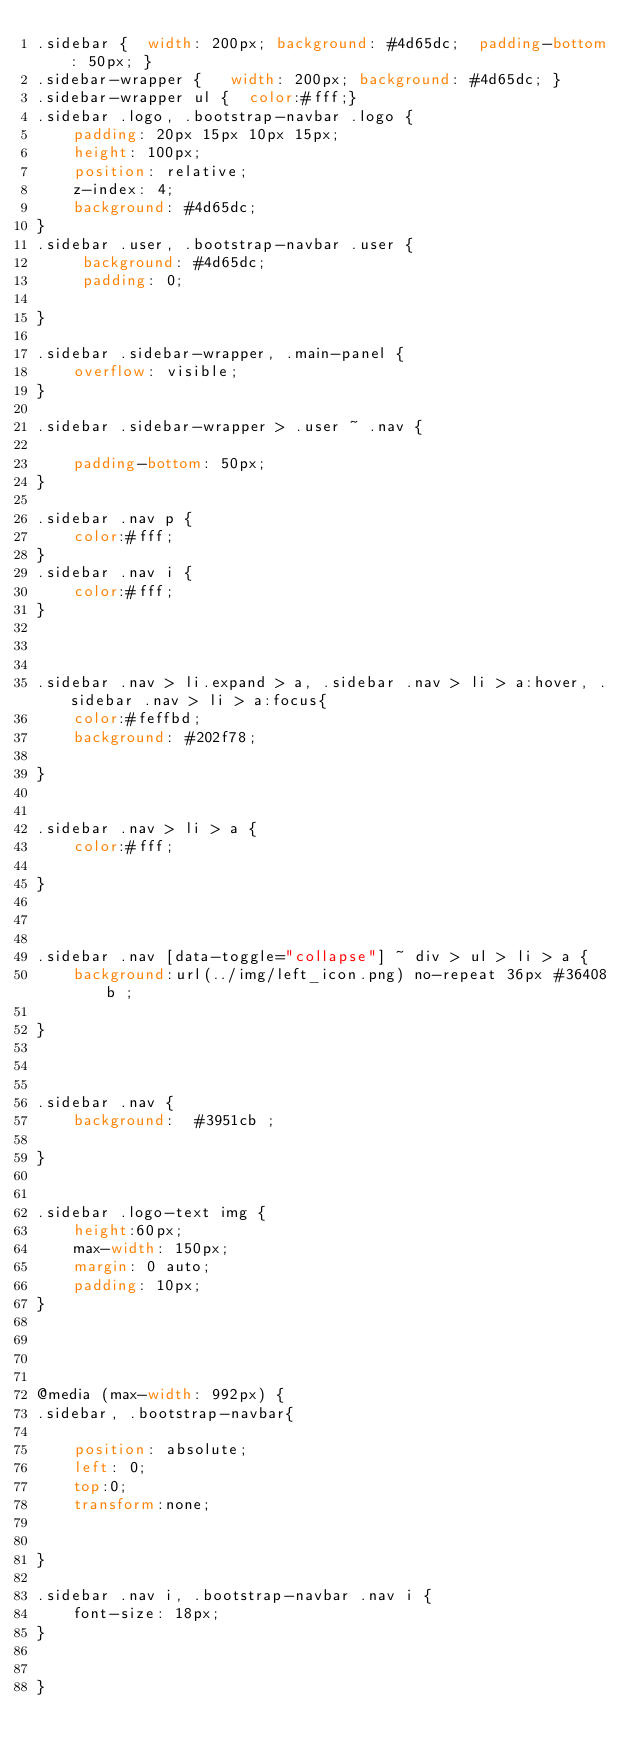Convert code to text. <code><loc_0><loc_0><loc_500><loc_500><_CSS_>.sidebar {  width: 200px; background: #4d65dc;  padding-bottom: 50px; }
.sidebar-wrapper {   width: 200px; background: #4d65dc; }
.sidebar-wrapper ul {  color:#fff;}
.sidebar .logo, .bootstrap-navbar .logo {
    padding: 20px 15px 10px 15px;
    height: 100px;
    position: relative;
    z-index: 4;
    background: #4d65dc;
}
.sidebar .user, .bootstrap-navbar .user {
	 background: #4d65dc;
	 padding: 0;
	
}

.sidebar .sidebar-wrapper, .main-panel {
    overflow: visible;
}

.sidebar .sidebar-wrapper > .user ~ .nav {
	
	padding-bottom: 50px;
}

.sidebar .nav p {
	color:#fff;
}
.sidebar .nav i {
	color:#fff;
}



.sidebar .nav > li.expand > a, .sidebar .nav > li > a:hover, .sidebar .nav > li > a:focus{
	color:#feffbd;	
	background: #202f78;
	
}


.sidebar .nav > li > a {
	color:#fff;	
	
}



.sidebar .nav [data-toggle="collapse"] ~ div > ul > li > a {
    background:url(../img/left_icon.png) no-repeat 36px #36408b ;
   
}



.sidebar .nav {
    background:  #3951cb ;
   
}


.sidebar .logo-text img {
	height:60px;
	max-width: 150px;
	margin: 0 auto;
	padding: 10px;
}




@media (max-width: 992px) {
.sidebar, .bootstrap-navbar{
	
	position: absolute;
	left: 0;
	top:0;
	transform:none;
	
	
}

.sidebar .nav i, .bootstrap-navbar .nav i {
    font-size: 18px;
}


}
</code> 